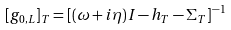<formula> <loc_0><loc_0><loc_500><loc_500>[ g _ { 0 , L } ] _ { T } = [ ( \omega + i \eta ) I - h _ { T } - \Sigma _ { T } ] ^ { - 1 }</formula> 